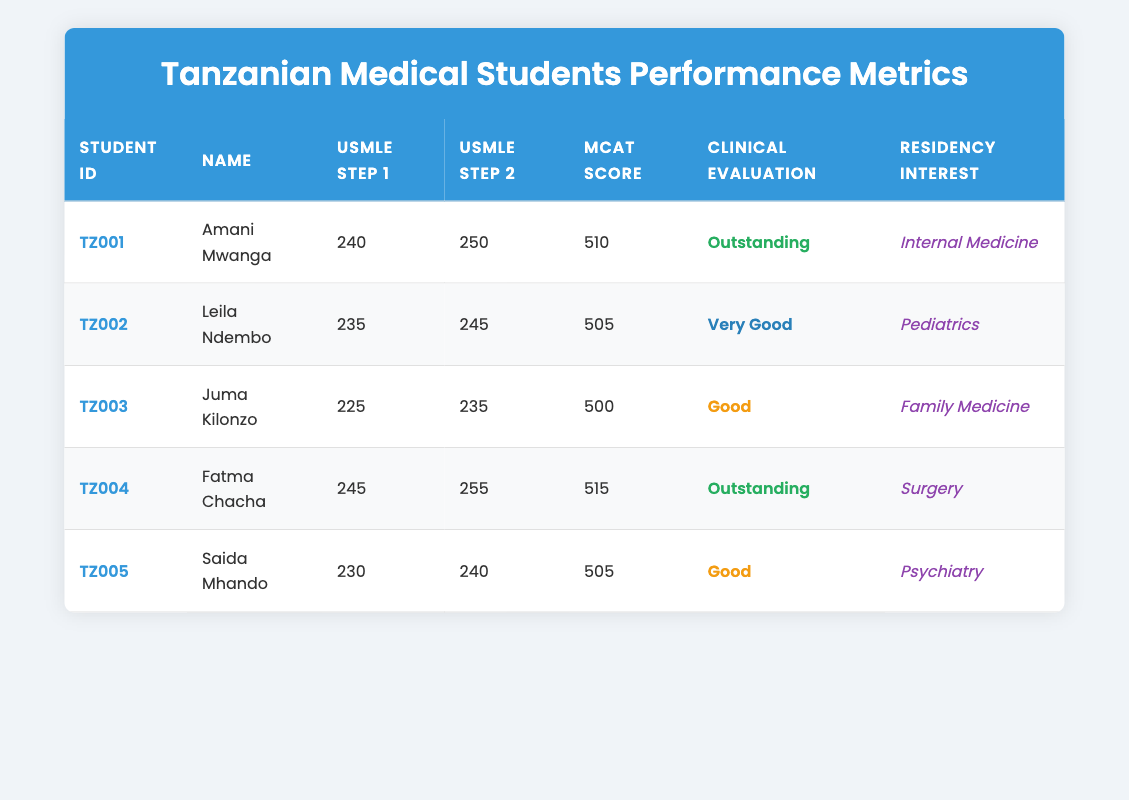What is the highest USMLE Step 1 score among the students? The table lists the USMLE Step 1 scores for each student. The highest score is found by comparing all scores: Amani Mwanga (240), Leila Ndembo (235), Juma Kilonzo (225), Fatma Chacha (245), and Saida Mhando (230). The highest score is 245 from Fatma Chacha.
Answer: 245 Which student has the lowest MCAT score? The MCAT scores are provided in the table for each student. The scores are: Amani Mwanga (510), Leila Ndembo (505), Juma Kilonzo (500), Fatma Chacha (515), and Saida Mhando (505). The lowest score is 500 from Juma Kilonzo.
Answer: Juma Kilonzo How many students scored above 240 in USMLE Step 2? The scores for USMLE Step 2 are compared to find how many are above 240. The scores are: Amani Mwanga (250), Leila Ndembo (245), Juma Kilonzo (235), Fatma Chacha (255), and Saida Mhando (240). Amani Mwanga, Leila Ndembo, and Fatma Chacha scored above 240, which is 3 students.
Answer: 3 Is there a student with “Outstanding” clinical evaluation that is interested in Pediatrics? The table shows the clinical evaluation scores and the corresponding residency interests. Checking the students who have "Outstanding" evaluations: Amani Mwanga (Internal Medicine) and Fatma Chacha (Surgery). Since neither is interested in Pediatrics, the answer is no.
Answer: No What is the average USMLE Step 1 score for all students? To calculate the average USMLE Step 1 score, sum all the scores: (240 + 235 + 225 + 245 + 230) = 1175. There are 5 students, so the average is 1175/5 = 235.
Answer: 235 Which residency interest is most common among the students listed? The residency interests for the students are: Amani Mwanga (Internal Medicine), Leila Ndembo (Pediatrics), Juma Kilonzo (Family Medicine), Fatma Chacha (Surgery), and Saida Mhando (Psychiatry). Each interest is unique, so none is repeated. The most common is "None."
Answer: None Which student has the best overall performance across all metrics? To determine the best overall performance, we compare scores and evaluations. Fatma Chacha has the highest scores (245 in Step 1 and 255 in Step 2) and an "Outstanding" evaluation, making her the top performer.
Answer: Fatma Chacha What is the difference in USMLE Step 2 score between the highest and lowest scoring students? The highest USMLE Step 2 score is 255 (Fatma Chacha) and the lowest is 235 (Juma Kilonzo). The difference is 255 - 235 = 20.
Answer: 20 